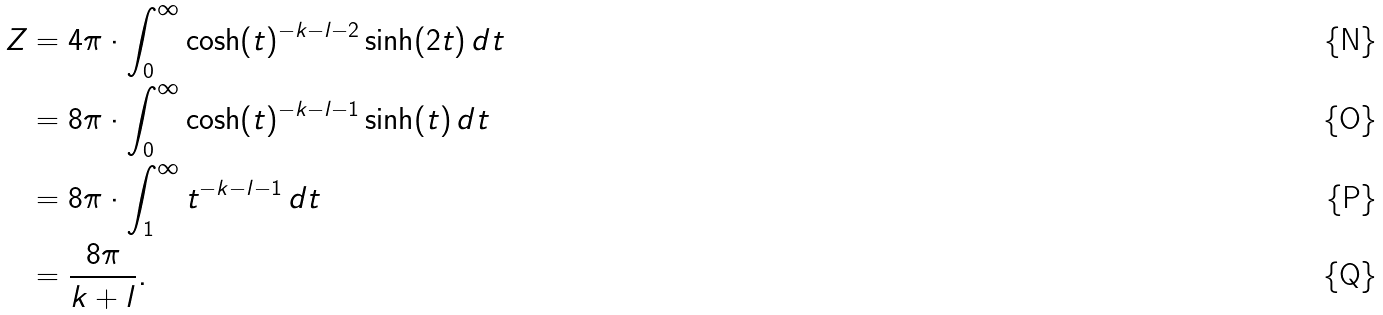Convert formula to latex. <formula><loc_0><loc_0><loc_500><loc_500>Z & = 4 \pi \cdot \int _ { 0 } ^ { \infty } \cosh ( t ) ^ { - k - l - 2 } \sinh ( 2 t ) \, d t \\ & = 8 \pi \cdot \int _ { 0 } ^ { \infty } \cosh ( t ) ^ { - k - l - 1 } \sinh ( t ) \, d t \\ & = 8 \pi \cdot \int _ { 1 } ^ { \infty } t ^ { - k - l - 1 } \, d t \\ & = \frac { 8 \pi } { k + l } .</formula> 